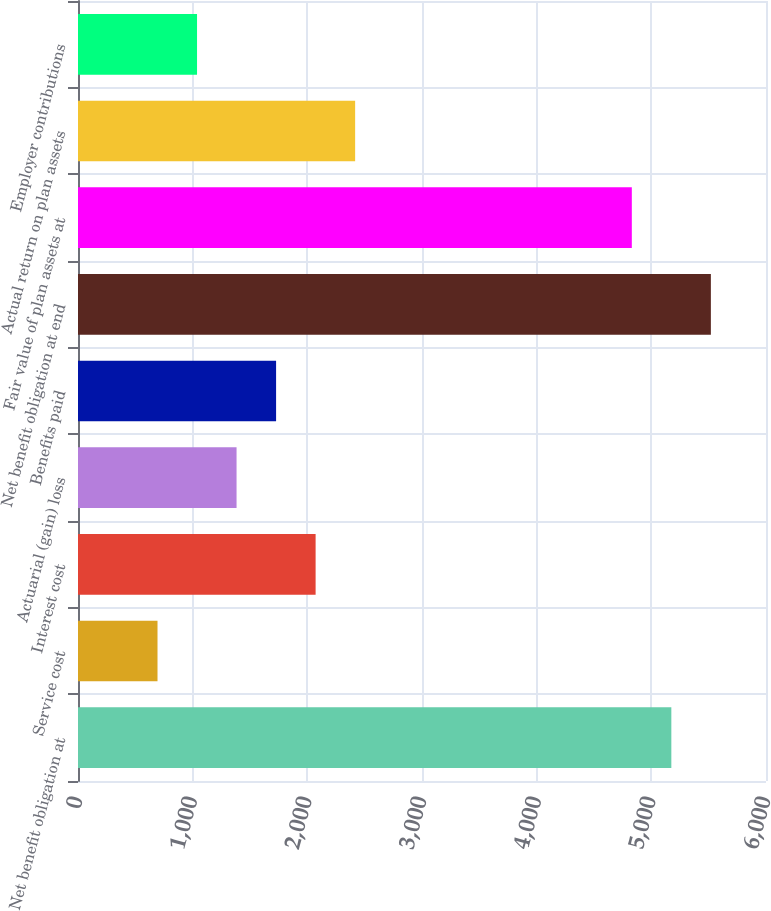Convert chart. <chart><loc_0><loc_0><loc_500><loc_500><bar_chart><fcel>Net benefit obligation at<fcel>Service cost<fcel>Interest cost<fcel>Actuarial (gain) loss<fcel>Benefits paid<fcel>Net benefit obligation at end<fcel>Fair value of plan assets at<fcel>Actual return on plan assets<fcel>Employer contributions<nl><fcel>5174.5<fcel>693.4<fcel>2072.2<fcel>1382.8<fcel>1727.5<fcel>5519.2<fcel>4829.8<fcel>2416.9<fcel>1038.1<nl></chart> 